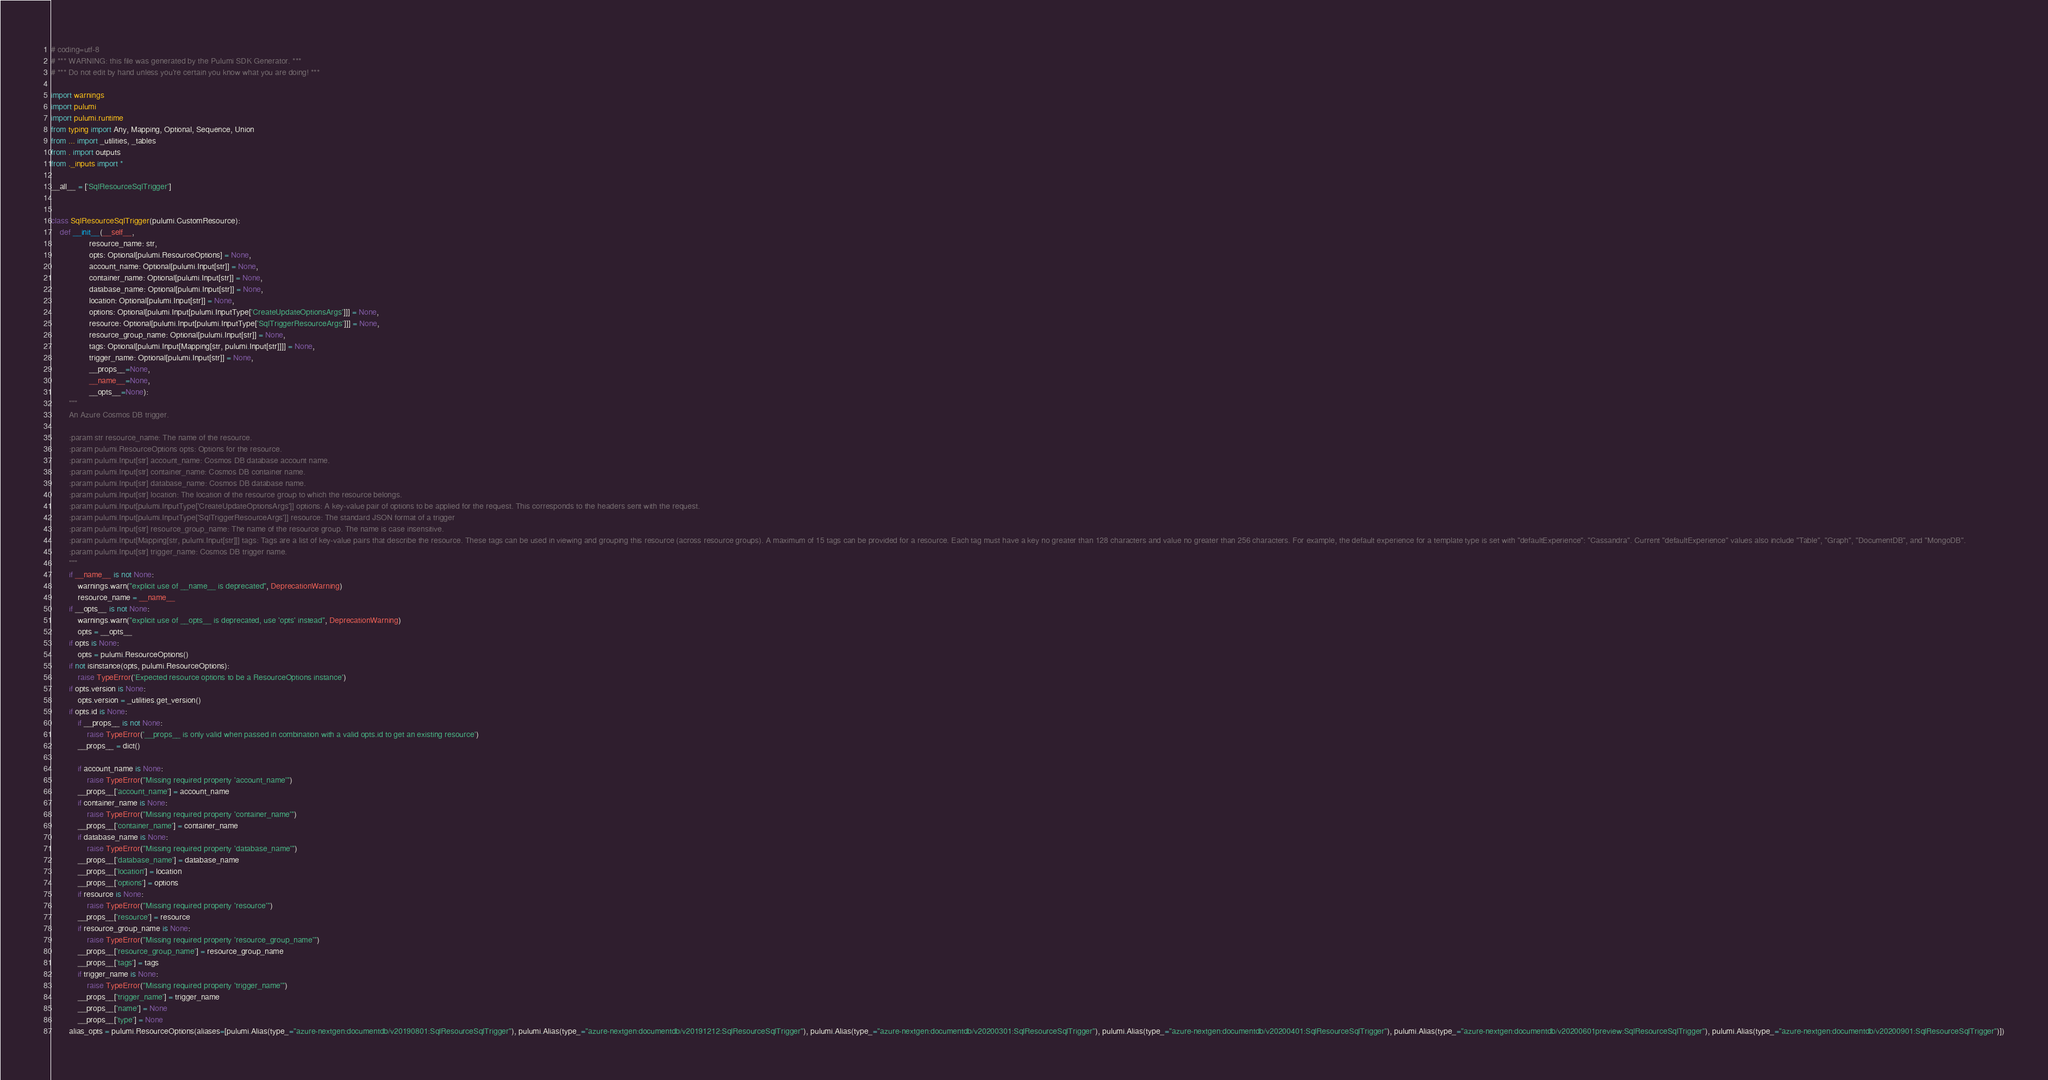Convert code to text. <code><loc_0><loc_0><loc_500><loc_500><_Python_># coding=utf-8
# *** WARNING: this file was generated by the Pulumi SDK Generator. ***
# *** Do not edit by hand unless you're certain you know what you are doing! ***

import warnings
import pulumi
import pulumi.runtime
from typing import Any, Mapping, Optional, Sequence, Union
from ... import _utilities, _tables
from . import outputs
from ._inputs import *

__all__ = ['SqlResourceSqlTrigger']


class SqlResourceSqlTrigger(pulumi.CustomResource):
    def __init__(__self__,
                 resource_name: str,
                 opts: Optional[pulumi.ResourceOptions] = None,
                 account_name: Optional[pulumi.Input[str]] = None,
                 container_name: Optional[pulumi.Input[str]] = None,
                 database_name: Optional[pulumi.Input[str]] = None,
                 location: Optional[pulumi.Input[str]] = None,
                 options: Optional[pulumi.Input[pulumi.InputType['CreateUpdateOptionsArgs']]] = None,
                 resource: Optional[pulumi.Input[pulumi.InputType['SqlTriggerResourceArgs']]] = None,
                 resource_group_name: Optional[pulumi.Input[str]] = None,
                 tags: Optional[pulumi.Input[Mapping[str, pulumi.Input[str]]]] = None,
                 trigger_name: Optional[pulumi.Input[str]] = None,
                 __props__=None,
                 __name__=None,
                 __opts__=None):
        """
        An Azure Cosmos DB trigger.

        :param str resource_name: The name of the resource.
        :param pulumi.ResourceOptions opts: Options for the resource.
        :param pulumi.Input[str] account_name: Cosmos DB database account name.
        :param pulumi.Input[str] container_name: Cosmos DB container name.
        :param pulumi.Input[str] database_name: Cosmos DB database name.
        :param pulumi.Input[str] location: The location of the resource group to which the resource belongs.
        :param pulumi.Input[pulumi.InputType['CreateUpdateOptionsArgs']] options: A key-value pair of options to be applied for the request. This corresponds to the headers sent with the request.
        :param pulumi.Input[pulumi.InputType['SqlTriggerResourceArgs']] resource: The standard JSON format of a trigger
        :param pulumi.Input[str] resource_group_name: The name of the resource group. The name is case insensitive.
        :param pulumi.Input[Mapping[str, pulumi.Input[str]]] tags: Tags are a list of key-value pairs that describe the resource. These tags can be used in viewing and grouping this resource (across resource groups). A maximum of 15 tags can be provided for a resource. Each tag must have a key no greater than 128 characters and value no greater than 256 characters. For example, the default experience for a template type is set with "defaultExperience": "Cassandra". Current "defaultExperience" values also include "Table", "Graph", "DocumentDB", and "MongoDB".
        :param pulumi.Input[str] trigger_name: Cosmos DB trigger name.
        """
        if __name__ is not None:
            warnings.warn("explicit use of __name__ is deprecated", DeprecationWarning)
            resource_name = __name__
        if __opts__ is not None:
            warnings.warn("explicit use of __opts__ is deprecated, use 'opts' instead", DeprecationWarning)
            opts = __opts__
        if opts is None:
            opts = pulumi.ResourceOptions()
        if not isinstance(opts, pulumi.ResourceOptions):
            raise TypeError('Expected resource options to be a ResourceOptions instance')
        if opts.version is None:
            opts.version = _utilities.get_version()
        if opts.id is None:
            if __props__ is not None:
                raise TypeError('__props__ is only valid when passed in combination with a valid opts.id to get an existing resource')
            __props__ = dict()

            if account_name is None:
                raise TypeError("Missing required property 'account_name'")
            __props__['account_name'] = account_name
            if container_name is None:
                raise TypeError("Missing required property 'container_name'")
            __props__['container_name'] = container_name
            if database_name is None:
                raise TypeError("Missing required property 'database_name'")
            __props__['database_name'] = database_name
            __props__['location'] = location
            __props__['options'] = options
            if resource is None:
                raise TypeError("Missing required property 'resource'")
            __props__['resource'] = resource
            if resource_group_name is None:
                raise TypeError("Missing required property 'resource_group_name'")
            __props__['resource_group_name'] = resource_group_name
            __props__['tags'] = tags
            if trigger_name is None:
                raise TypeError("Missing required property 'trigger_name'")
            __props__['trigger_name'] = trigger_name
            __props__['name'] = None
            __props__['type'] = None
        alias_opts = pulumi.ResourceOptions(aliases=[pulumi.Alias(type_="azure-nextgen:documentdb/v20190801:SqlResourceSqlTrigger"), pulumi.Alias(type_="azure-nextgen:documentdb/v20191212:SqlResourceSqlTrigger"), pulumi.Alias(type_="azure-nextgen:documentdb/v20200301:SqlResourceSqlTrigger"), pulumi.Alias(type_="azure-nextgen:documentdb/v20200401:SqlResourceSqlTrigger"), pulumi.Alias(type_="azure-nextgen:documentdb/v20200601preview:SqlResourceSqlTrigger"), pulumi.Alias(type_="azure-nextgen:documentdb/v20200901:SqlResourceSqlTrigger")])</code> 